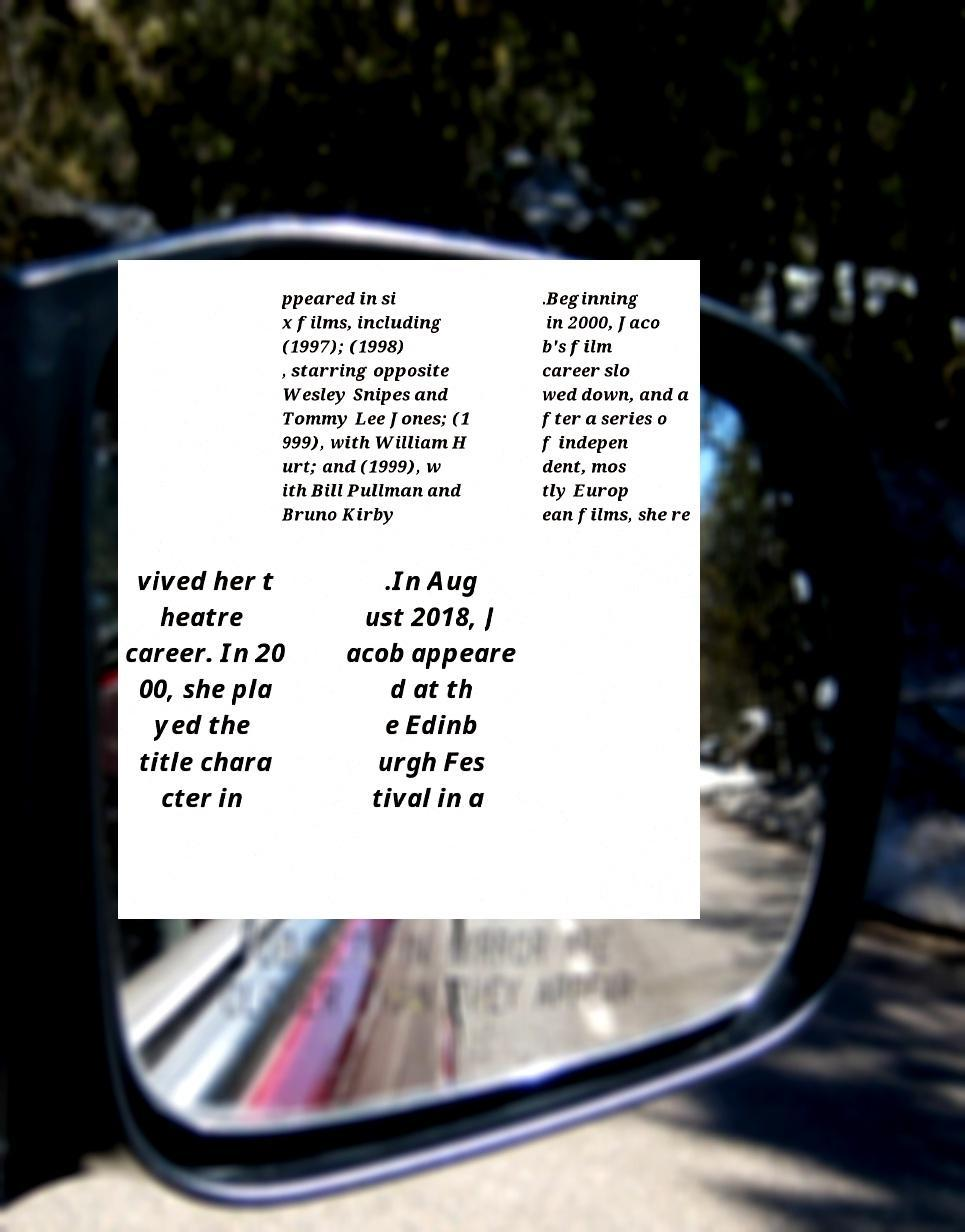Can you accurately transcribe the text from the provided image for me? ppeared in si x films, including (1997); (1998) , starring opposite Wesley Snipes and Tommy Lee Jones; (1 999), with William H urt; and (1999), w ith Bill Pullman and Bruno Kirby .Beginning in 2000, Jaco b's film career slo wed down, and a fter a series o f indepen dent, mos tly Europ ean films, she re vived her t heatre career. In 20 00, she pla yed the title chara cter in .In Aug ust 2018, J acob appeare d at th e Edinb urgh Fes tival in a 